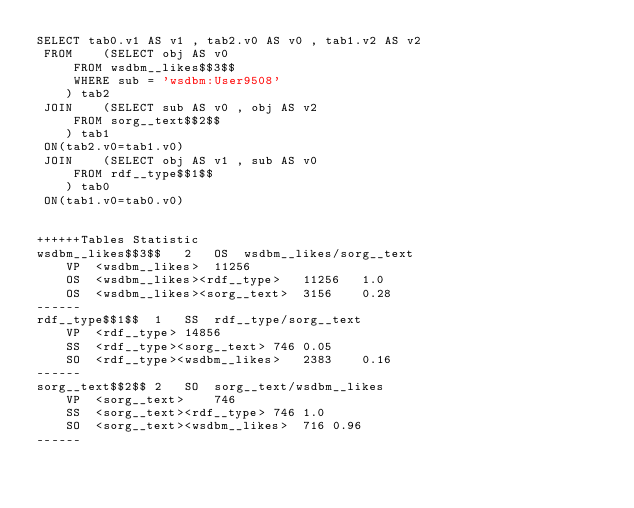<code> <loc_0><loc_0><loc_500><loc_500><_SQL_>SELECT tab0.v1 AS v1 , tab2.v0 AS v0 , tab1.v2 AS v2 
 FROM    (SELECT obj AS v0 
	 FROM wsdbm__likes$$3$$ 
	 WHERE sub = 'wsdbm:User9508'
	) tab2
 JOIN    (SELECT sub AS v0 , obj AS v2 
	 FROM sorg__text$$2$$
	) tab1
 ON(tab2.v0=tab1.v0)
 JOIN    (SELECT obj AS v1 , sub AS v0 
	 FROM rdf__type$$1$$
	) tab0
 ON(tab1.v0=tab0.v0)


++++++Tables Statistic
wsdbm__likes$$3$$	2	OS	wsdbm__likes/sorg__text
	VP	<wsdbm__likes>	11256
	OS	<wsdbm__likes><rdf__type>	11256	1.0
	OS	<wsdbm__likes><sorg__text>	3156	0.28
------
rdf__type$$1$$	1	SS	rdf__type/sorg__text
	VP	<rdf__type>	14856
	SS	<rdf__type><sorg__text>	746	0.05
	SO	<rdf__type><wsdbm__likes>	2383	0.16
------
sorg__text$$2$$	2	SO	sorg__text/wsdbm__likes
	VP	<sorg__text>	746
	SS	<sorg__text><rdf__type>	746	1.0
	SO	<sorg__text><wsdbm__likes>	716	0.96
------
</code> 